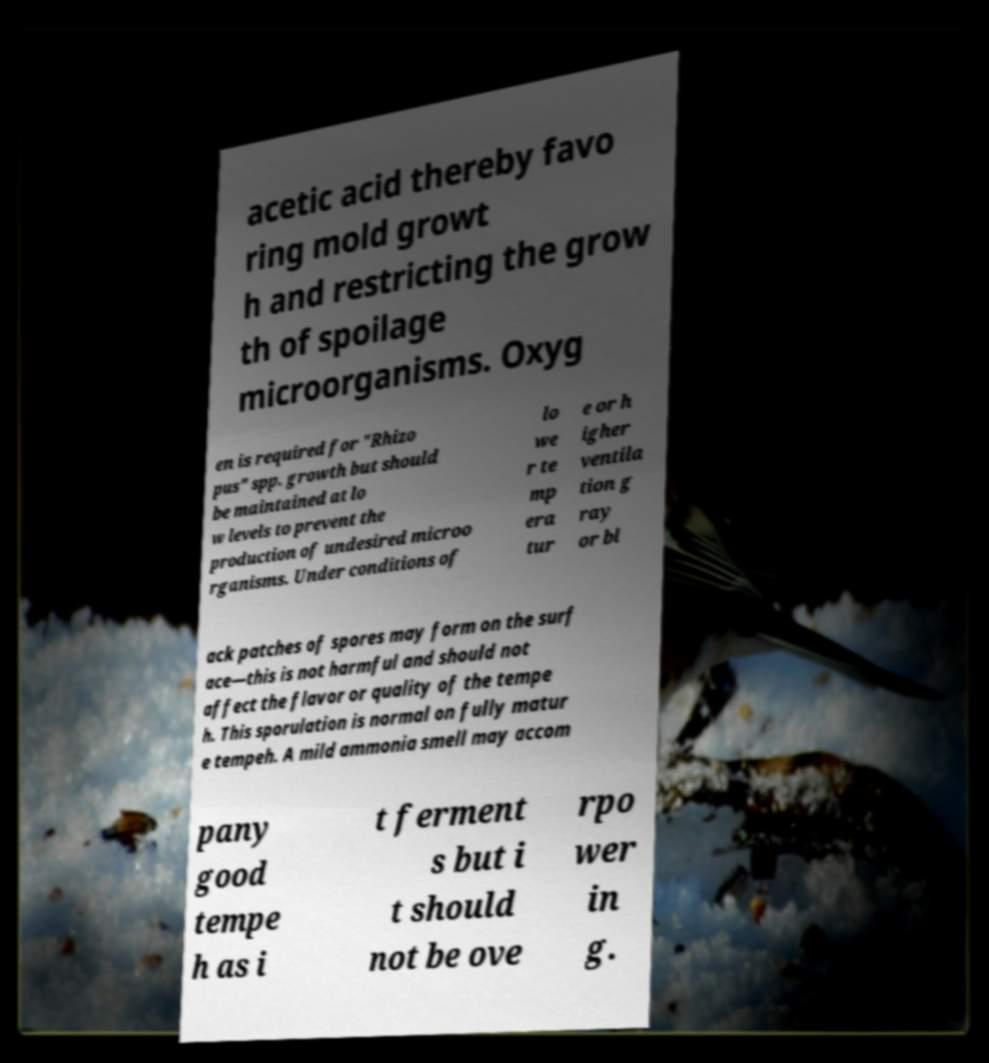Can you accurately transcribe the text from the provided image for me? acetic acid thereby favo ring mold growt h and restricting the grow th of spoilage microorganisms. Oxyg en is required for "Rhizo pus" spp. growth but should be maintained at lo w levels to prevent the production of undesired microo rganisms. Under conditions of lo we r te mp era tur e or h igher ventila tion g ray or bl ack patches of spores may form on the surf ace—this is not harmful and should not affect the flavor or quality of the tempe h. This sporulation is normal on fully matur e tempeh. A mild ammonia smell may accom pany good tempe h as i t ferment s but i t should not be ove rpo wer in g. 